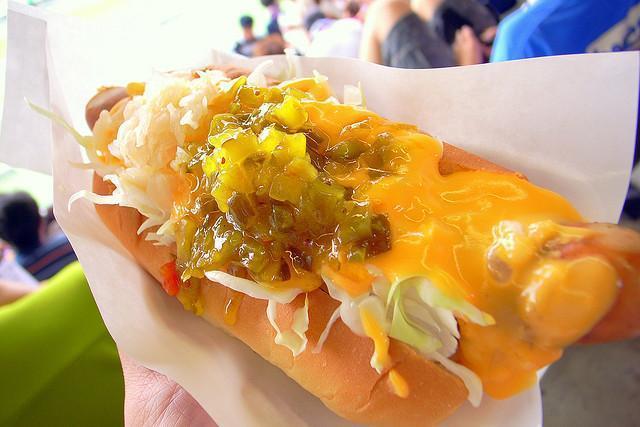How many toppings are on this hot dog?
Give a very brief answer. 4. How many people are there?
Give a very brief answer. 5. 